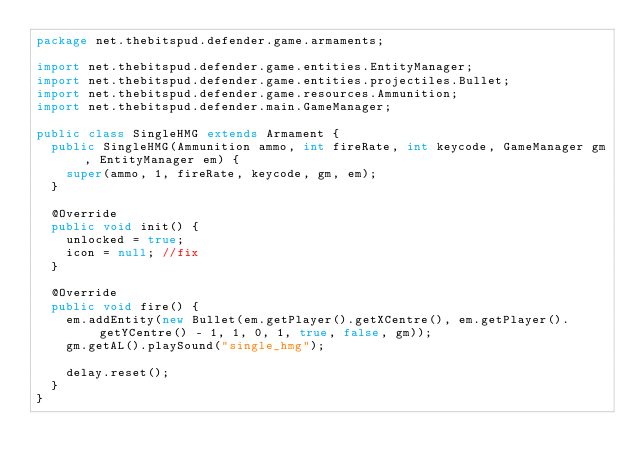Convert code to text. <code><loc_0><loc_0><loc_500><loc_500><_Java_>package net.thebitspud.defender.game.armaments;

import net.thebitspud.defender.game.entities.EntityManager;
import net.thebitspud.defender.game.entities.projectiles.Bullet;
import net.thebitspud.defender.game.resources.Ammunition;
import net.thebitspud.defender.main.GameManager;

public class SingleHMG extends Armament {
	public SingleHMG(Ammunition ammo, int fireRate, int keycode, GameManager gm, EntityManager em) {
		super(ammo, 1, fireRate, keycode, gm, em);
	}

	@Override
	public void init() {
		unlocked = true;
		icon = null; //fix
	}

	@Override
	public void fire() {
		em.addEntity(new Bullet(em.getPlayer().getXCentre(), em.getPlayer().getYCentre() - 1, 1, 0, 1, true, false, gm));
		gm.getAL().playSound("single_hmg");
		
		delay.reset();
	}
}</code> 